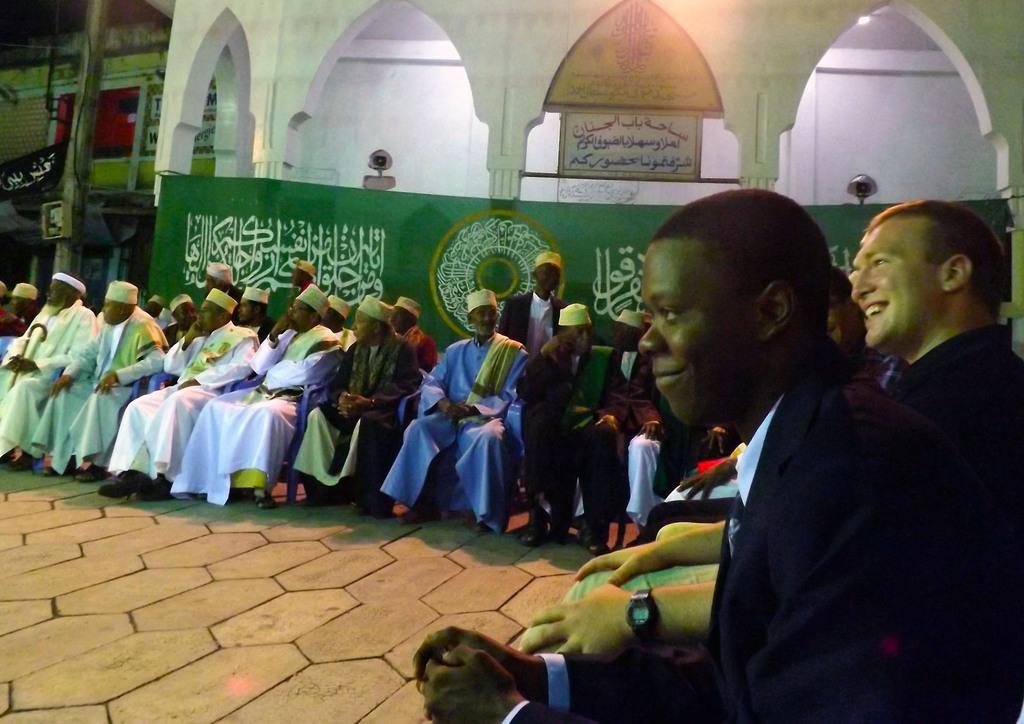Can you describe this image briefly? This image is taken in the mosque. In this image we can see people sitting on the chairs which are on the floor. On the right we can see people smiling. We can also see some text on the boards. On the left there is a wooden pole and also a black color flag. Light is also visible. 